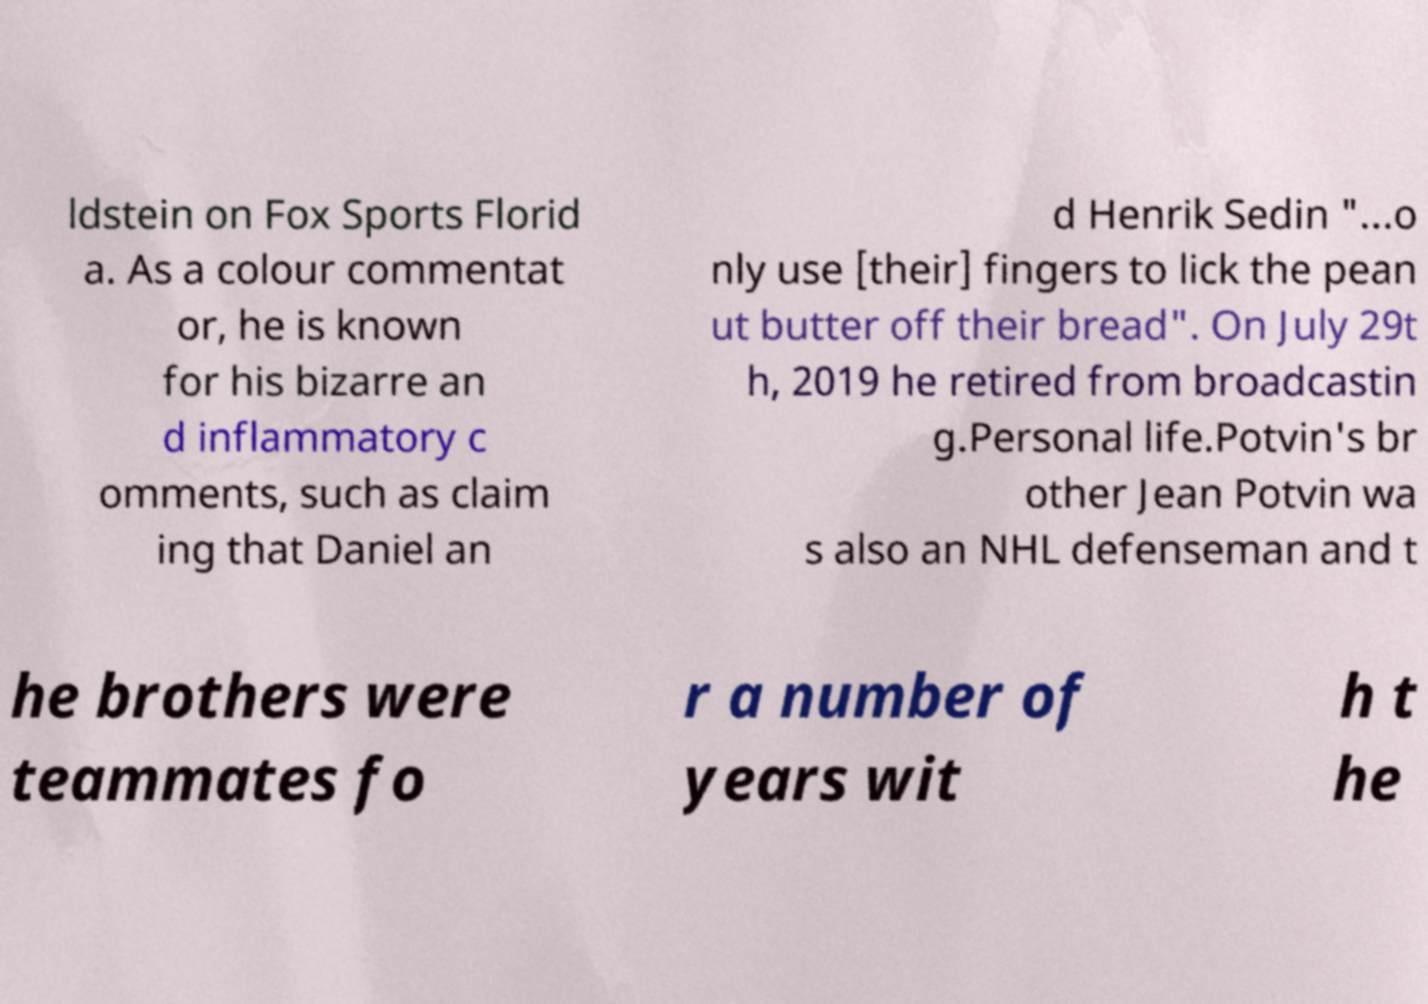What messages or text are displayed in this image? I need them in a readable, typed format. ldstein on Fox Sports Florid a. As a colour commentat or, he is known for his bizarre an d inflammatory c omments, such as claim ing that Daniel an d Henrik Sedin "...o nly use [their] fingers to lick the pean ut butter off their bread". On July 29t h, 2019 he retired from broadcastin g.Personal life.Potvin's br other Jean Potvin wa s also an NHL defenseman and t he brothers were teammates fo r a number of years wit h t he 